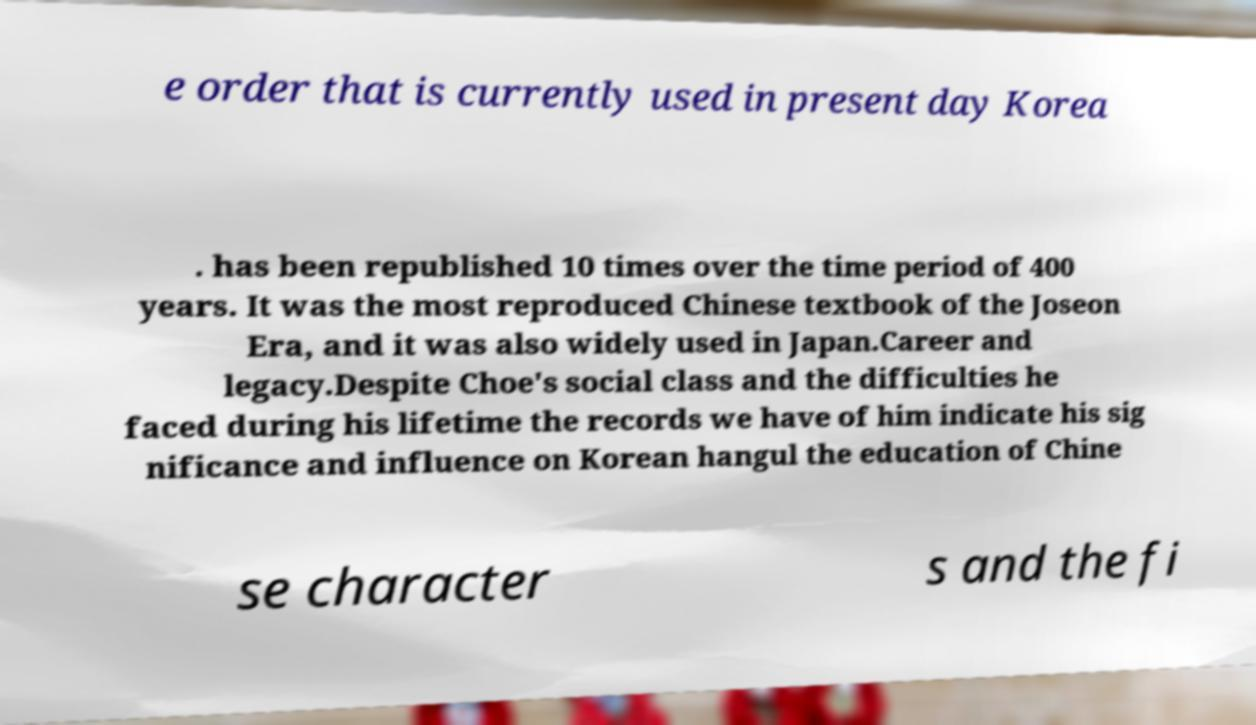Please identify and transcribe the text found in this image. e order that is currently used in present day Korea . has been republished 10 times over the time period of 400 years. It was the most reproduced Chinese textbook of the Joseon Era, and it was also widely used in Japan.Career and legacy.Despite Choe's social class and the difficulties he faced during his lifetime the records we have of him indicate his sig nificance and influence on Korean hangul the education of Chine se character s and the fi 